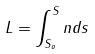<formula> <loc_0><loc_0><loc_500><loc_500>L = \int _ { S _ { o } } ^ { S } n d s</formula> 